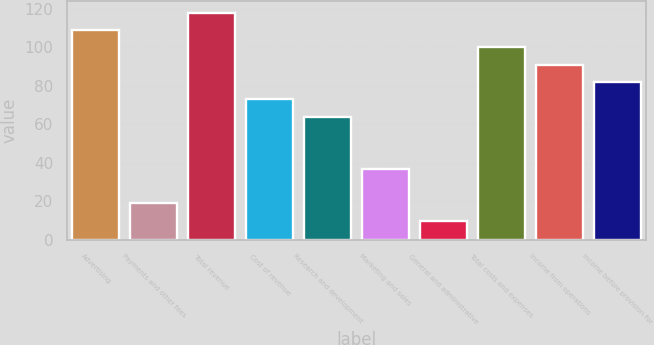Convert chart to OTSL. <chart><loc_0><loc_0><loc_500><loc_500><bar_chart><fcel>Advertising<fcel>Payments and other fees<fcel>Total revenue<fcel>Cost of revenue<fcel>Research and development<fcel>Marketing and sales<fcel>General and administrative<fcel>Total costs and expenses<fcel>Income from operations<fcel>Income before provision for<nl><fcel>109<fcel>19<fcel>118<fcel>73<fcel>64<fcel>37<fcel>10<fcel>100<fcel>91<fcel>82<nl></chart> 